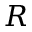Convert formula to latex. <formula><loc_0><loc_0><loc_500><loc_500>R</formula> 